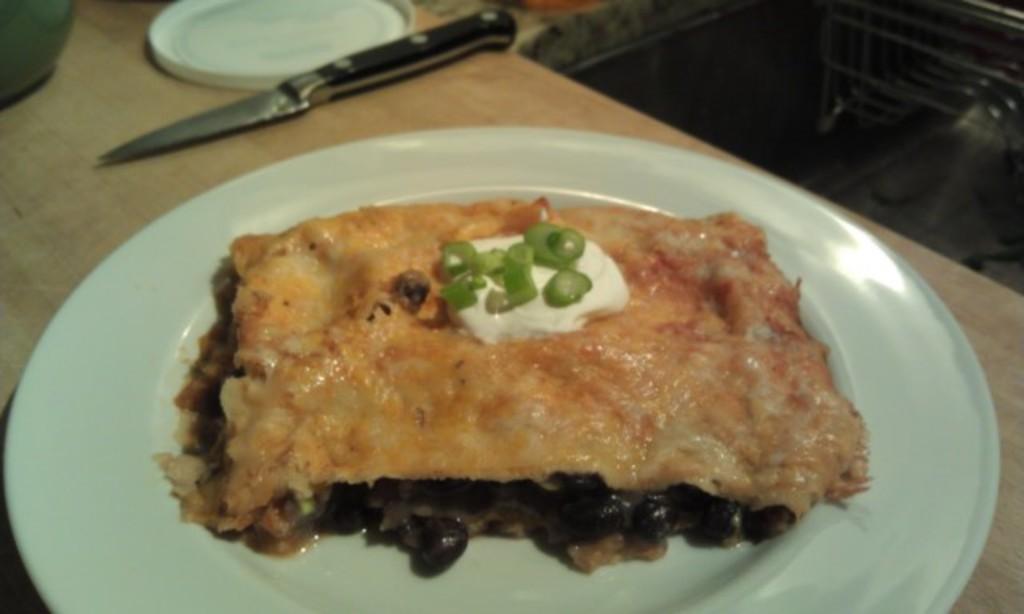Describe this image in one or two sentences. In this image we can see a wooden surface. On that there is a plate with food item, knife and some other things. 